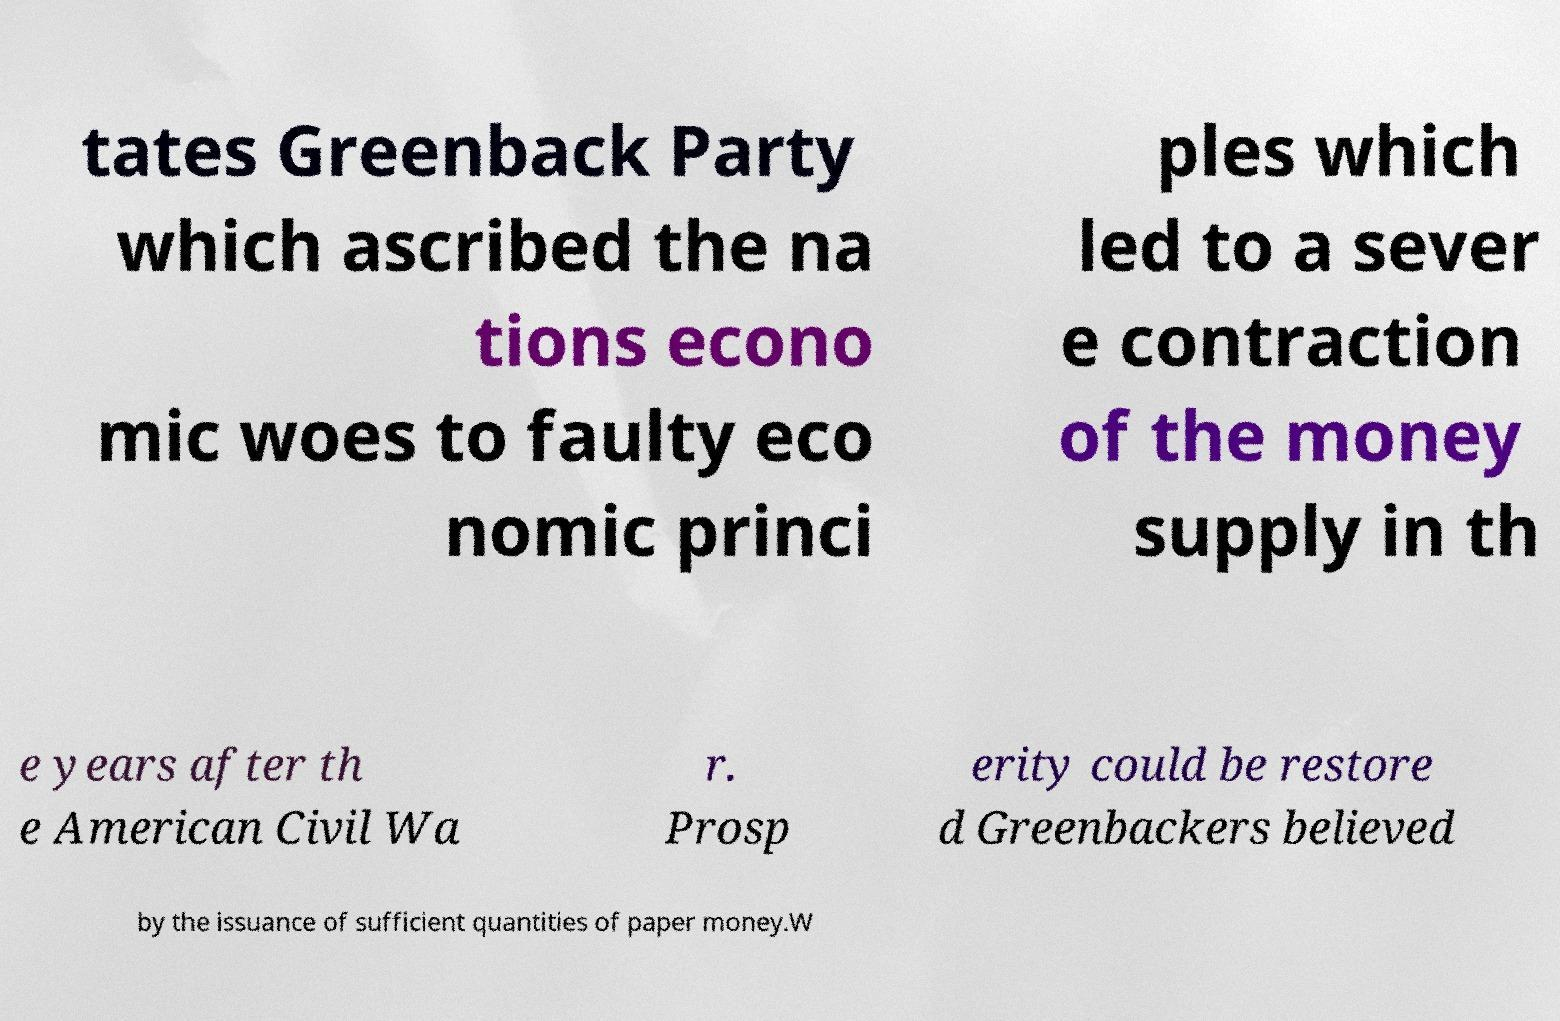Can you read and provide the text displayed in the image?This photo seems to have some interesting text. Can you extract and type it out for me? tates Greenback Party which ascribed the na tions econo mic woes to faulty eco nomic princi ples which led to a sever e contraction of the money supply in th e years after th e American Civil Wa r. Prosp erity could be restore d Greenbackers believed by the issuance of sufficient quantities of paper money.W 